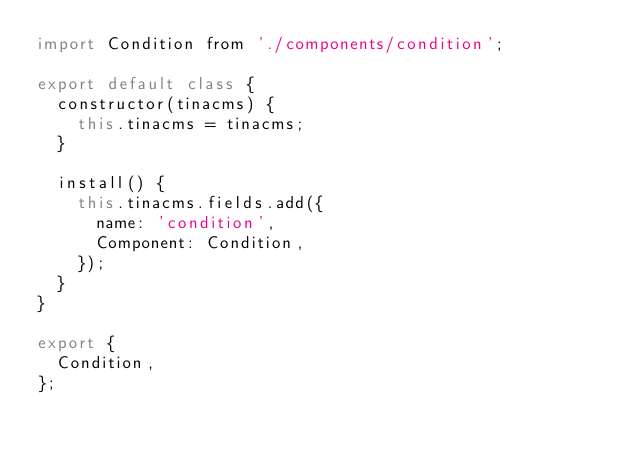Convert code to text. <code><loc_0><loc_0><loc_500><loc_500><_JavaScript_>import Condition from './components/condition';

export default class {
  constructor(tinacms) {
    this.tinacms = tinacms;
  }

  install() {
    this.tinacms.fields.add({
      name: 'condition',
      Component: Condition,
    });
  }
}

export {
  Condition,
};
</code> 